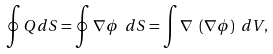<formula> <loc_0><loc_0><loc_500><loc_500>\oint Q d S = \oint \nabla \phi \ d S = \int \nabla \ ( \nabla \phi ) \ d V ,</formula> 